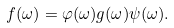<formula> <loc_0><loc_0><loc_500><loc_500>f ( \omega ) = \varphi ( \omega ) g ( \omega ) \psi ( \omega ) .</formula> 